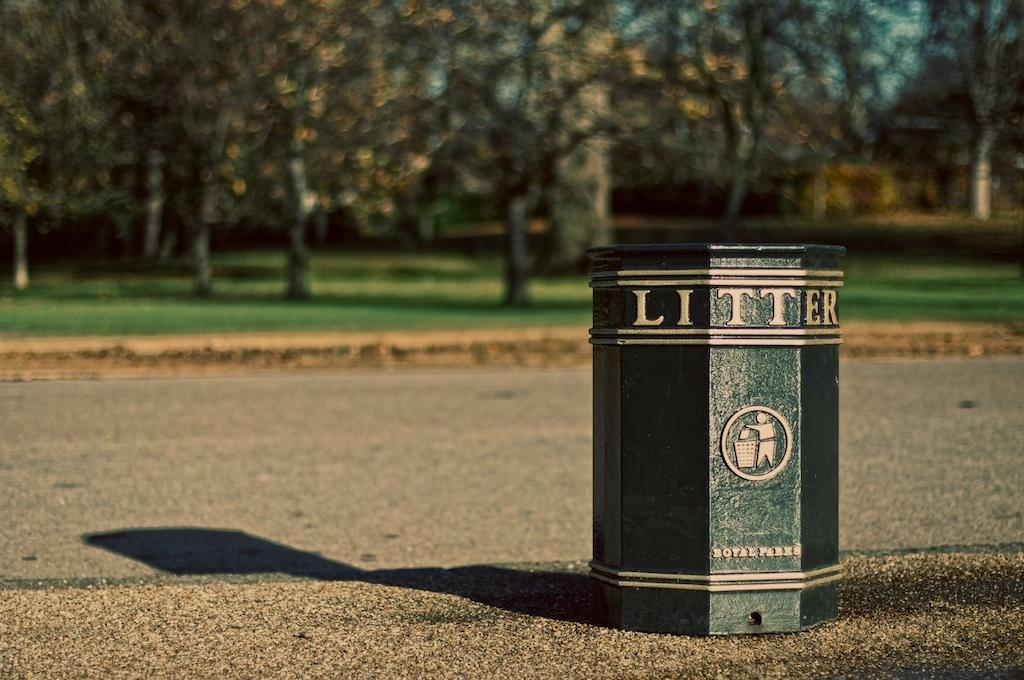Provide a one-sentence caption for the provided image. A trash can in the park is printed with the work LITTER at the top. 